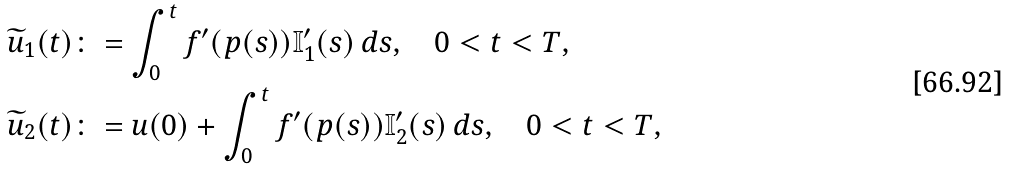Convert formula to latex. <formula><loc_0><loc_0><loc_500><loc_500>\widetilde { u } _ { 1 } ( t ) & \colon = \int _ { 0 } ^ { t } f ^ { \prime } ( p ( s ) ) \mathbb { I } _ { 1 } ^ { \prime } ( s ) \, d s , \quad 0 < t < T , \\ \widetilde { u } _ { 2 } ( t ) & \colon = u ( 0 ) + \int _ { 0 } ^ { t } f ^ { \prime } ( p ( s ) ) \mathbb { I } _ { 2 } ^ { \prime } ( s ) \, d s , \quad 0 < t < T ,</formula> 